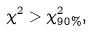Convert formula to latex. <formula><loc_0><loc_0><loc_500><loc_500>\chi ^ { 2 } > \chi ^ { 2 } _ { 9 0 \% } ,</formula> 